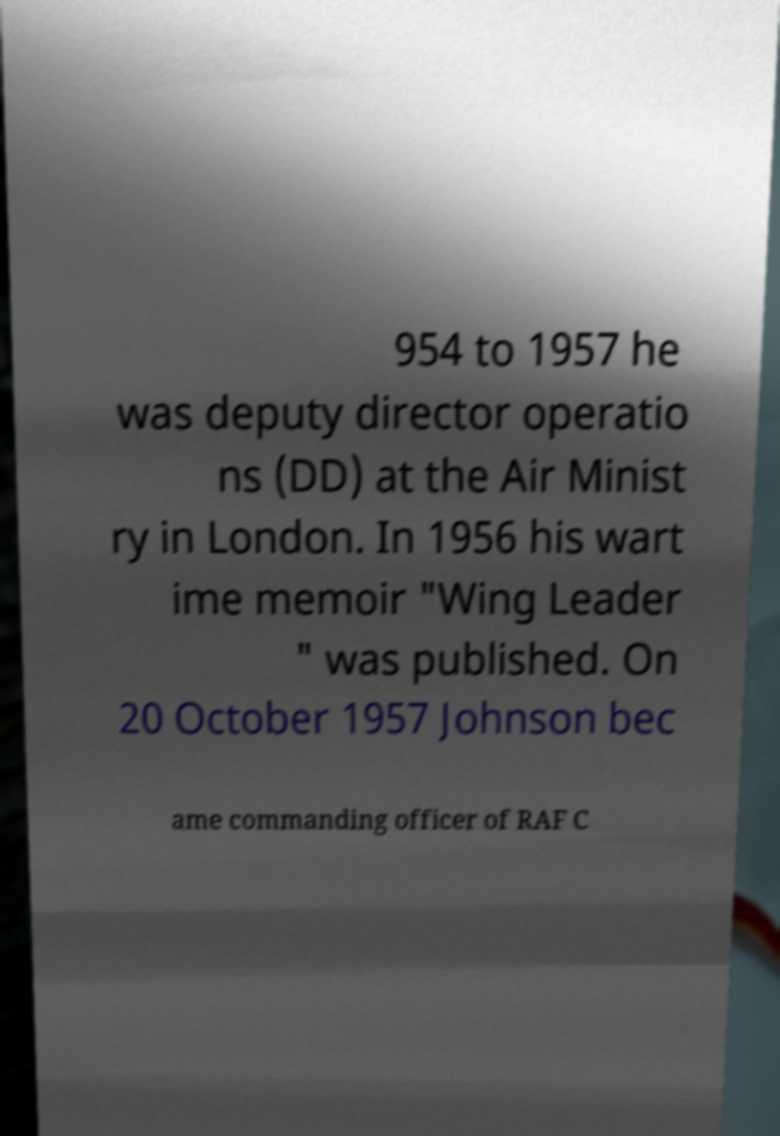For documentation purposes, I need the text within this image transcribed. Could you provide that? 954 to 1957 he was deputy director operatio ns (DD) at the Air Minist ry in London. In 1956 his wart ime memoir "Wing Leader " was published. On 20 October 1957 Johnson bec ame commanding officer of RAF C 